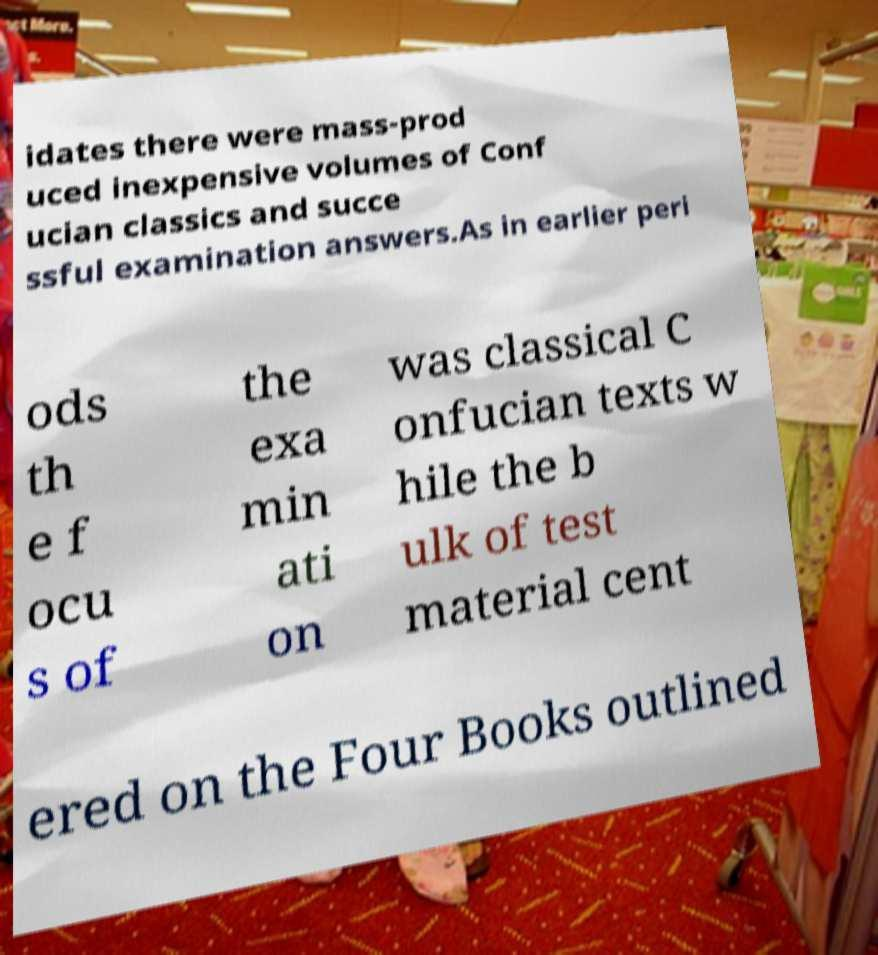Can you accurately transcribe the text from the provided image for me? idates there were mass-prod uced inexpensive volumes of Conf ucian classics and succe ssful examination answers.As in earlier peri ods th e f ocu s of the exa min ati on was classical C onfucian texts w hile the b ulk of test material cent ered on the Four Books outlined 